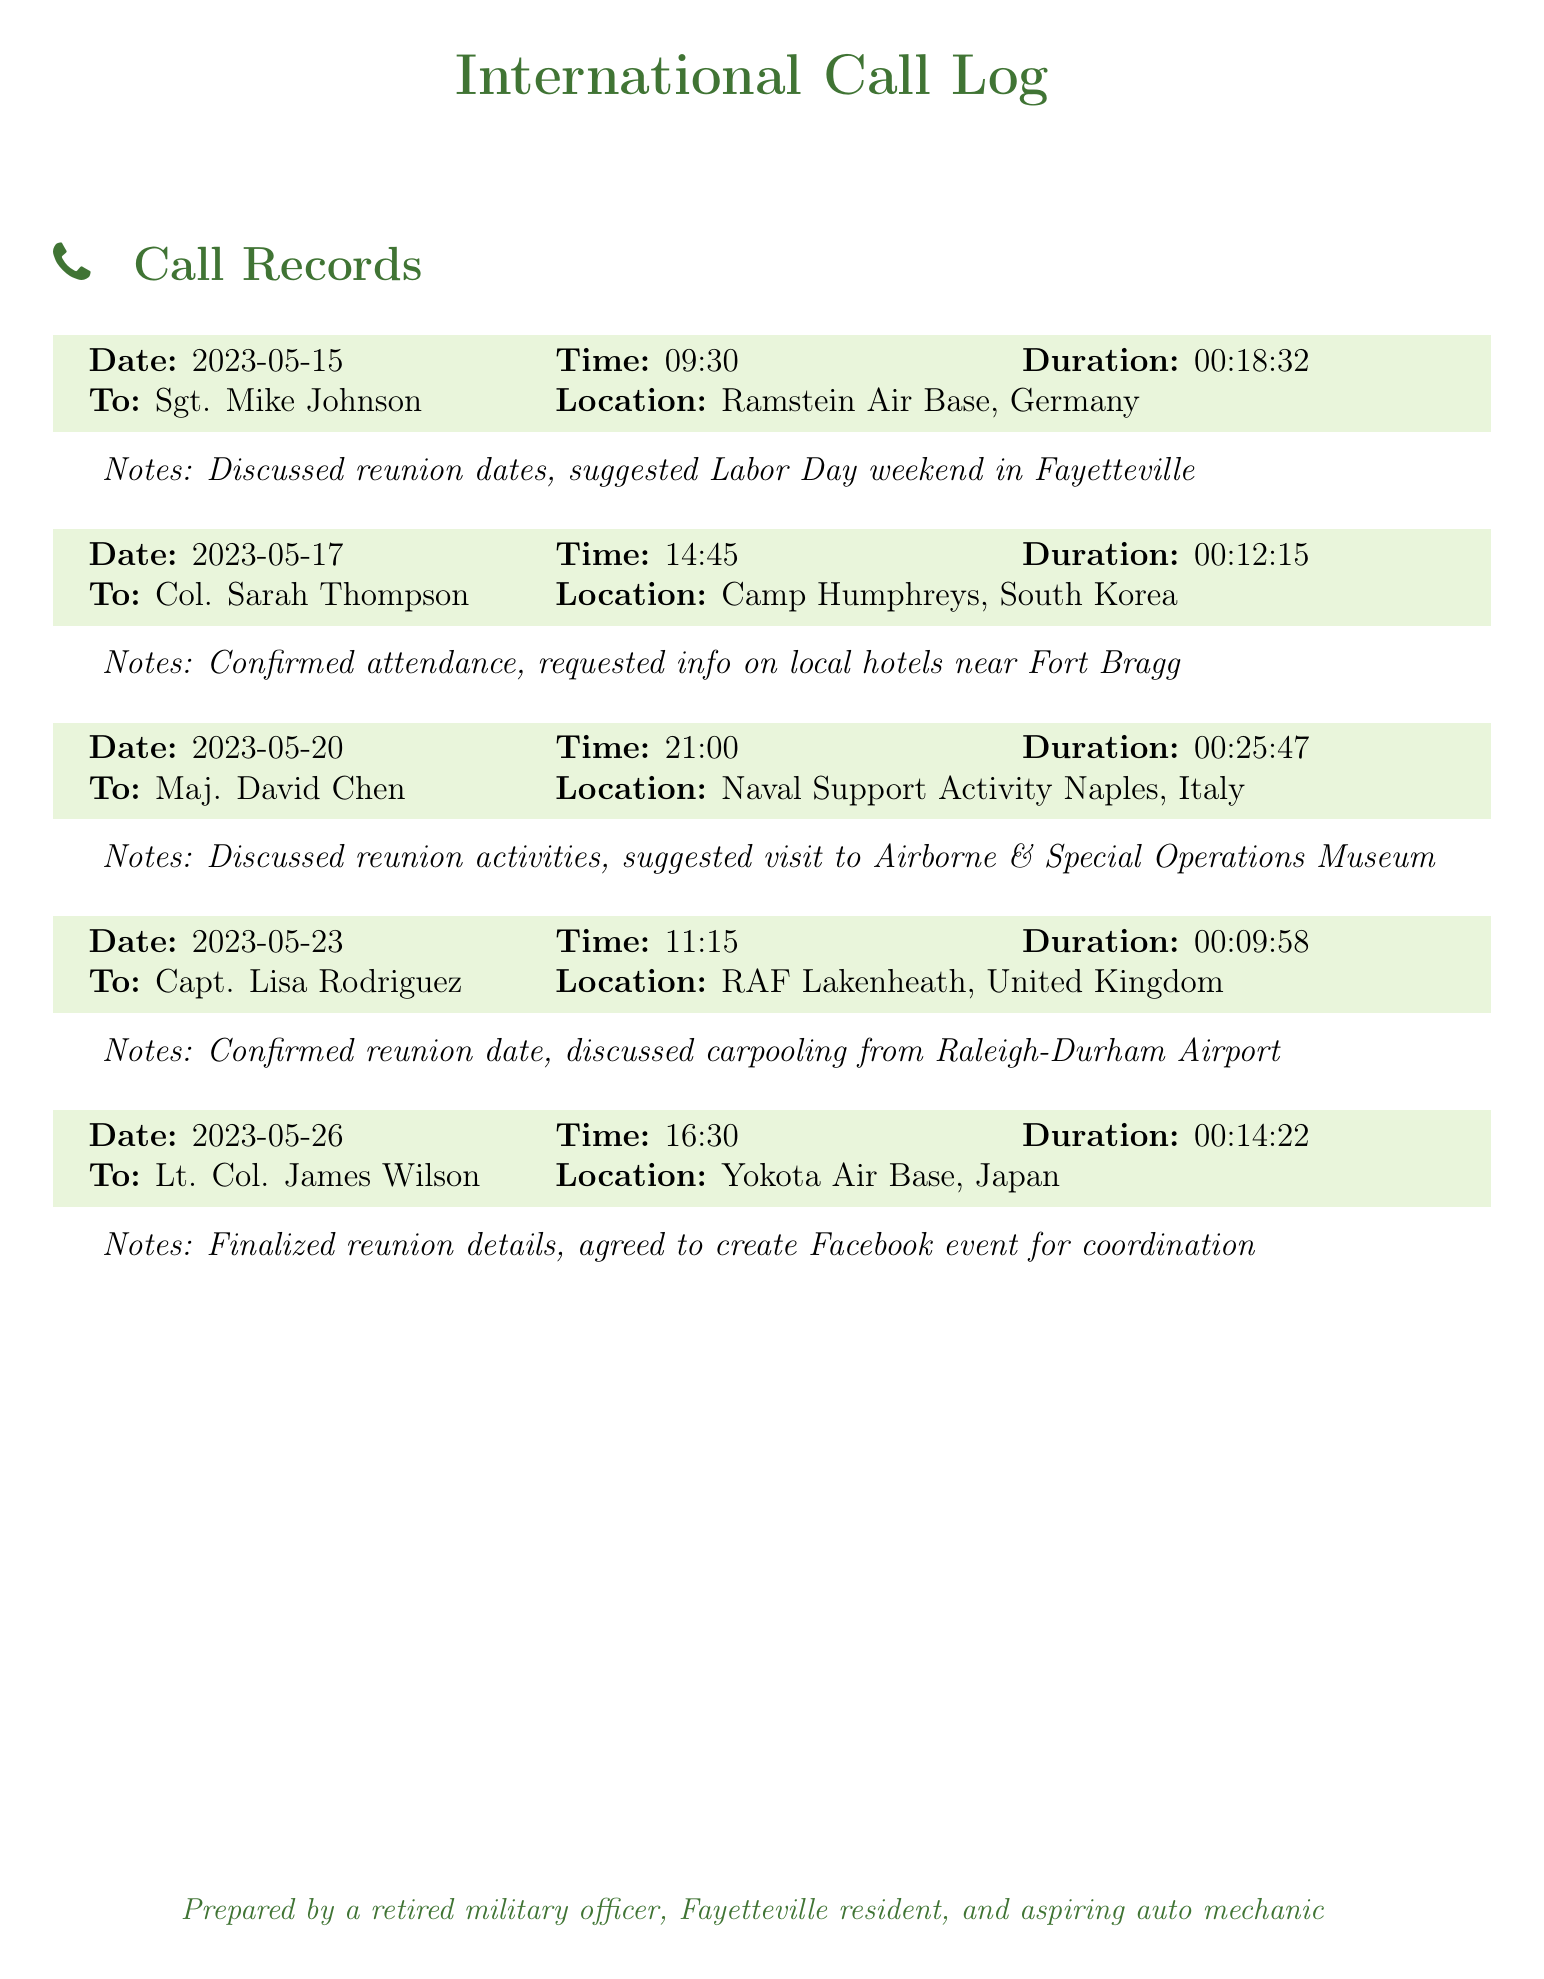What is the date of the call to Sgt. Mike Johnson? The date of the call can be found at the beginning of the entry for Sgt. Mike Johnson, which is May 15, 2023.
Answer: May 15, 2023 What was the duration of the call to Capt. Lisa Rodriguez? The duration is explicitly mentioned in the entry for Capt. Lisa Rodriguez, which is 00:09:58.
Answer: 00:09:58 Which military base did Maj. David Chen call from? The location is noted in the entry for Maj. David Chen, which is Naval Support Activity Naples, Italy.
Answer: Naval Support Activity Naples, Italy How many calls were made in total? The number of entries indicates the total calls made, which is five.
Answer: 5 What weekend was suggested for the reunion? The notes for the call to Sgt. Mike Johnson state that Labor Day weekend was suggested.
Answer: Labor Day weekend Who confirmed their attendance during the call on May 17? The call on May 17 was with Col. Sarah Thompson, who confirmed attendance.
Answer: Col. Sarah Thompson What activity was suggested during the call with Maj. David Chen? The notes mention a visit to the Airborne & Special Operations Museum was suggested.
Answer: Visit to Airborne & Special Operations Museum What coordination method was agreed upon during the call with Lt. Col. James Wilson? The notes indicate they agreed to create a Facebook event for coordination.
Answer: Create Facebook event 